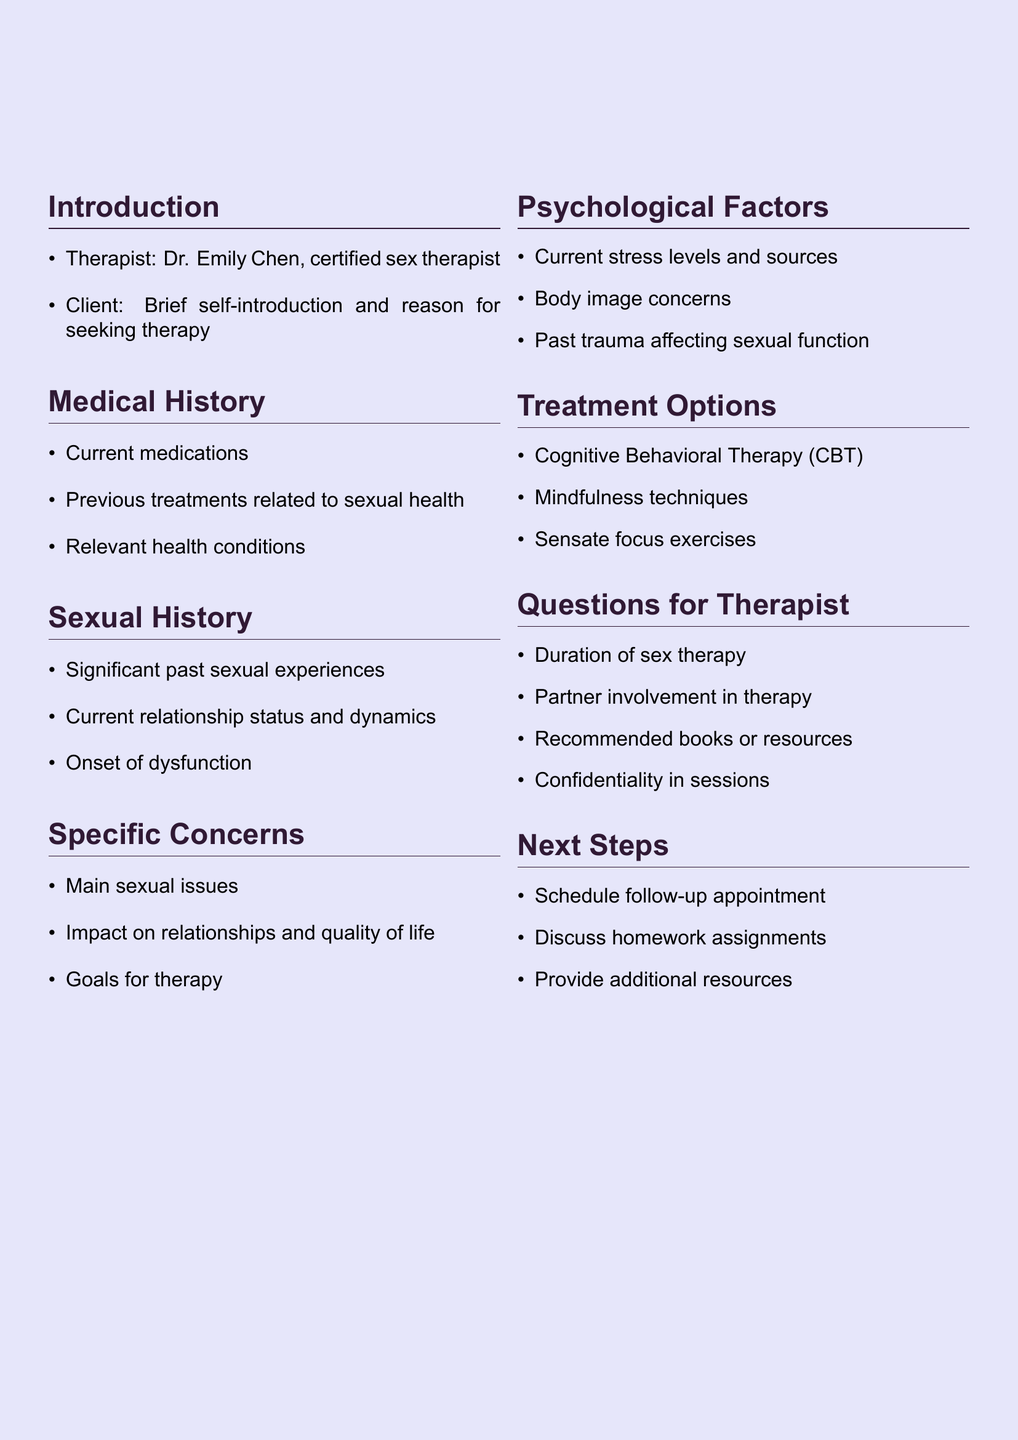What is the name of the therapist? The document states the therapist's name as Dr. Emily Chen.
Answer: Dr. Emily Chen What should the client provide during self-introduction? The document indicates that the client should give a brief self-introduction and the reason for seeking therapy.
Answer: Brief self-introduction and reason for seeking therapy Which treatment option involves addressing negative thought patterns? The section on treatment options mentions Cognitive Behavioral Therapy (CBT) for this purpose.
Answer: Cognitive Behavioral Therapy (CBT) What are the main sexual issues being addressed? The specific concerns section asks the client to describe the main sexual issues they are experiencing.
Answer: Main sexual issues What is one psychological factor discussed in the agenda? The document includes stress levels as a psychological factor that should be discussed.
Answer: Current stress levels How does the agenda suggest the client follow up after the session? The next steps section outlines scheduling a follow-up appointment.
Answer: Schedule follow-up appointment Is partner involvement addressed in the therapy process? The questions for the therapist include whether the partner needs to be involved in the therapy process.
Answer: Partner involvement in therapy What does the agenda recommend for additional resources? The next steps section mentions providing additional resources that are relevant to the therapy process.
Answer: Provide additional resources 